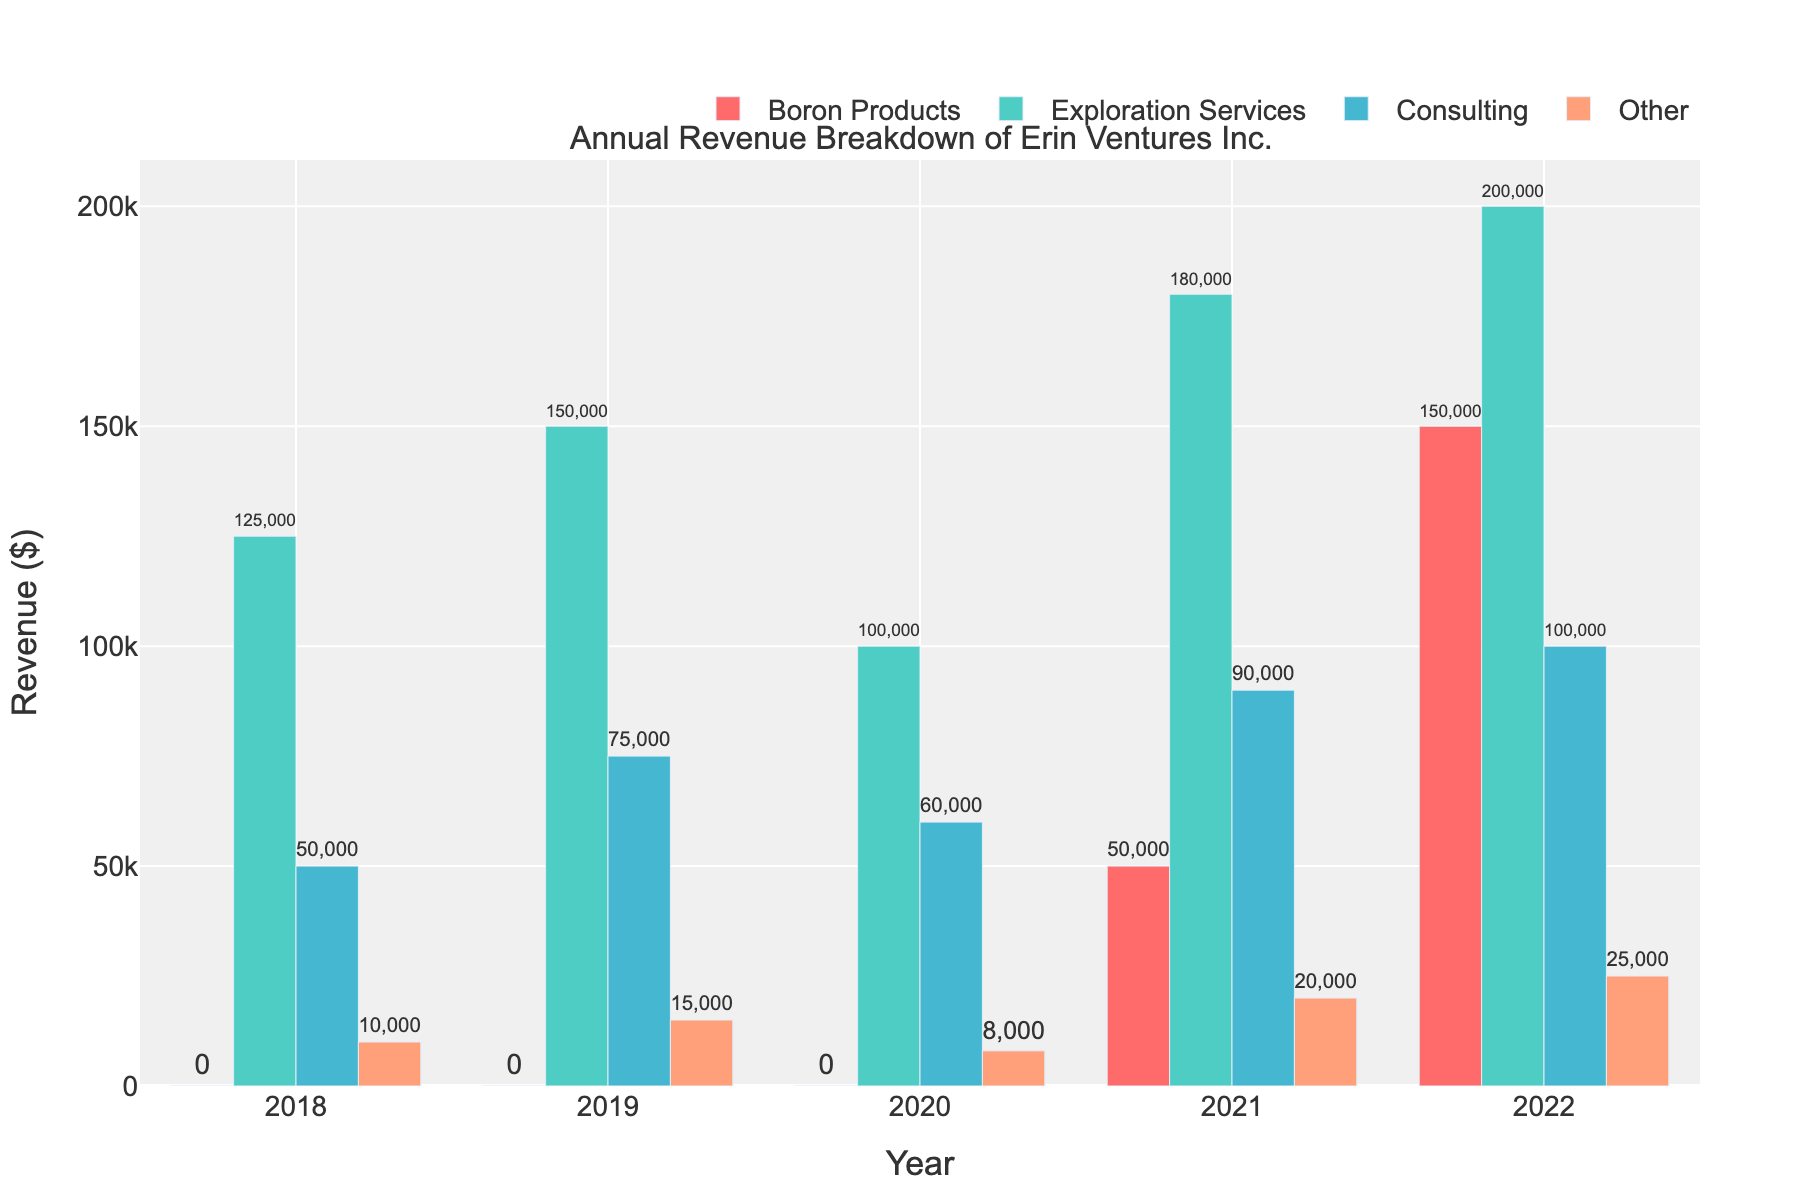What year did Erin Ventures Inc. start generating revenue from Boron Products? Boron Products show no revenue in 2018, 2019, and 2020. Revenue from Boron Products appears in 2021.
Answer: 2021 Which year did Erin Ventures Inc. have the highest total annual revenue? Total annual revenue is the sum of revenues from all categories for each year. Calculate: 2018 (185,000), 2019 (240,000), 2020 (168,000), 2021 (340,000), 2022 (475,000). 2022 has the highest total.
Answer: 2022 What is the difference in revenue from Exploration Services between 2018 and 2022? Revenue from Exploration Services in 2022 is $200,000 and in 2018 is $125,000. The difference is $200,000 - $125,000 = $75,000.
Answer: $75,000 By how much did the total revenue from Consulting change from 2018 to 2022? Revenue from Consulting in 2018 is $50,000 and in 2022 is $100,000. The change is $100,000 - $50,000 = $50,000.
Answer: $50,000 Comparing 2020 and 2021, which year had higher revenue from Other services, and by how much? Revenue from Other services in 2020 is $8,000, while in 2021 it is $20,000. 2021 had higher revenue by $20,000 - $8,000 = $12,000.
Answer: 2021, $12,000 What percentage of the total revenue in 2022 came from Boron Products? First, calculate total revenue for 2022: $375,000. Revenue from Boron Products is $150,000. The percentage is ($150,000 / $475,000) * 100% = 31.6% approximately.
Answer: 31.6% Between 2019 and 2022, which year's Consulting revenue showed the largest increase compared to the previous year? Compare increments: 2018-2019 ($75,000 - $50,000 = $25,000), 2019-2020 ($60,000 - $75,000 = - $15,000), 2020-2021 ($90,000 - $60,000 = $30,000), and 2021-2022 ($100,000 - $90,000 = $10,000). 2020-2021 shows the largest increase by $30,000.
Answer: 2020-2021 Which category has the most consistent revenue trends from 2018 to 2022? Looking at the bars for each category, Other Services appear to have relatively small changes each year.
Answer: Other What was the average annual revenue from Exploration Services over the period 2018-2022? Sum revenue from Exploration Services over the years: $125,000 + $150,000 + $100,000 + $180,000 + $200,000 = $755,000. Divide by 5 years: $755,000 / 5 = $151,000.
Answer: $151,000 